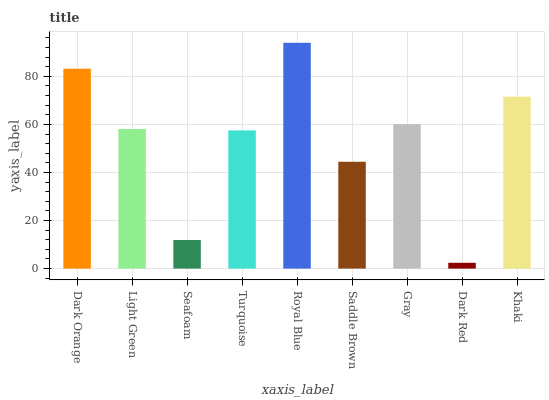Is Dark Red the minimum?
Answer yes or no. Yes. Is Royal Blue the maximum?
Answer yes or no. Yes. Is Light Green the minimum?
Answer yes or no. No. Is Light Green the maximum?
Answer yes or no. No. Is Dark Orange greater than Light Green?
Answer yes or no. Yes. Is Light Green less than Dark Orange?
Answer yes or no. Yes. Is Light Green greater than Dark Orange?
Answer yes or no. No. Is Dark Orange less than Light Green?
Answer yes or no. No. Is Light Green the high median?
Answer yes or no. Yes. Is Light Green the low median?
Answer yes or no. Yes. Is Dark Red the high median?
Answer yes or no. No. Is Turquoise the low median?
Answer yes or no. No. 